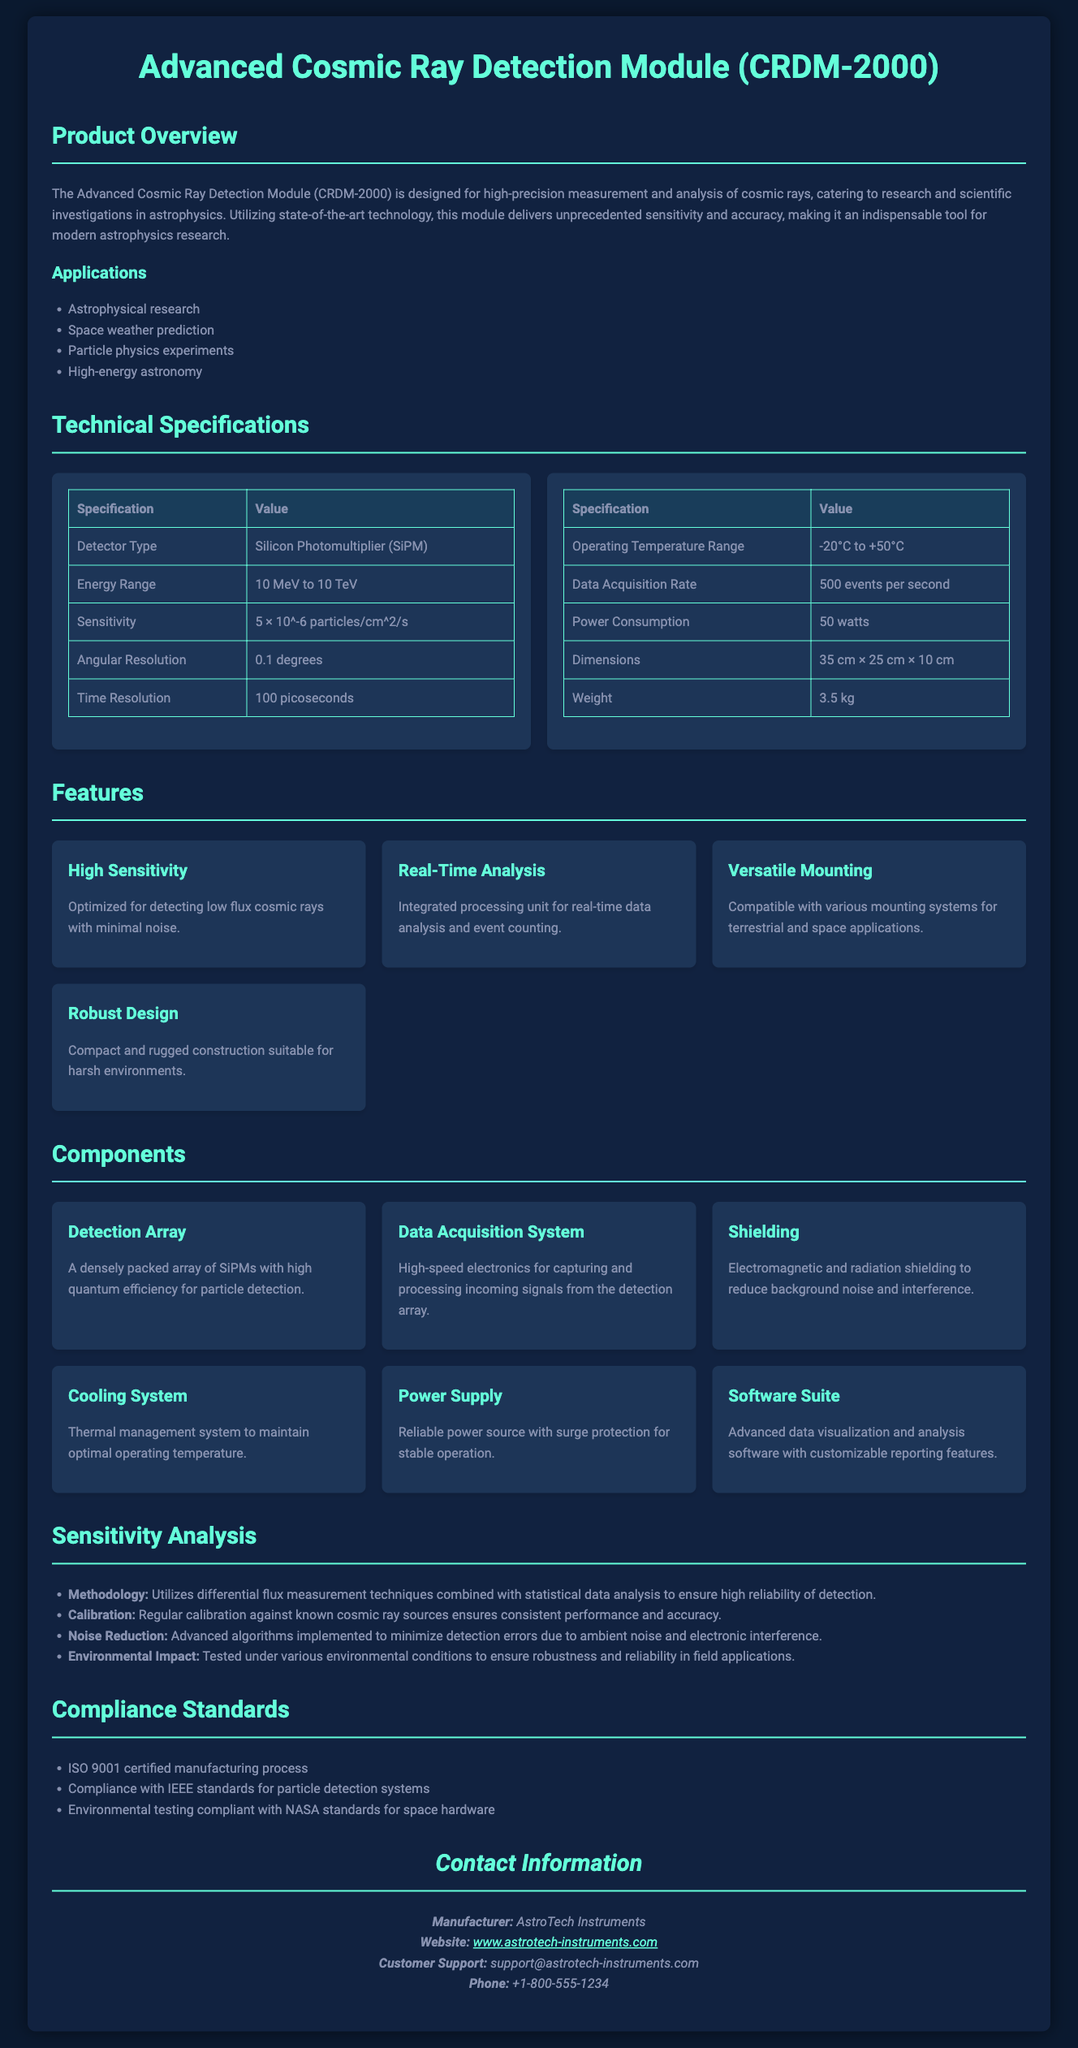what is the product name? The product name is stated in the title section of the document.
Answer: Advanced Cosmic Ray Detection Module (CRDM-2000) what is the sensitivity value? The sensitivity value can be found in the Technical Specifications table.
Answer: 5 × 10^-6 particles/cm^2/s what is the operating temperature range? The operating temperature range is located in the Technical Specifications section.
Answer: -20°C to +50°C how many events can the module acquire per second? The data acquisition rate is mentioned in the Technical Specifications section.
Answer: 500 events per second what type of detector is used? The type of detector is specified in the Technical Specifications table.
Answer: Silicon Photomultiplier (SiPM) what features ensure minimal noise detection? This reasoning requires integrating information from features and sensitivity analysis sections.
Answer: High Sensitivity and Noise Reduction which compliance standard is mentioned? The compliance standards section lists the certification.
Answer: ISO 9001 certified manufacturing process what component is responsible for thermal management? The components section outlines the purpose of each component in the module.
Answer: Cooling System how is calibration maintained? The sensitivity analysis describes how calibration is performed.
Answer: Regular calibration against known cosmic ray sources 